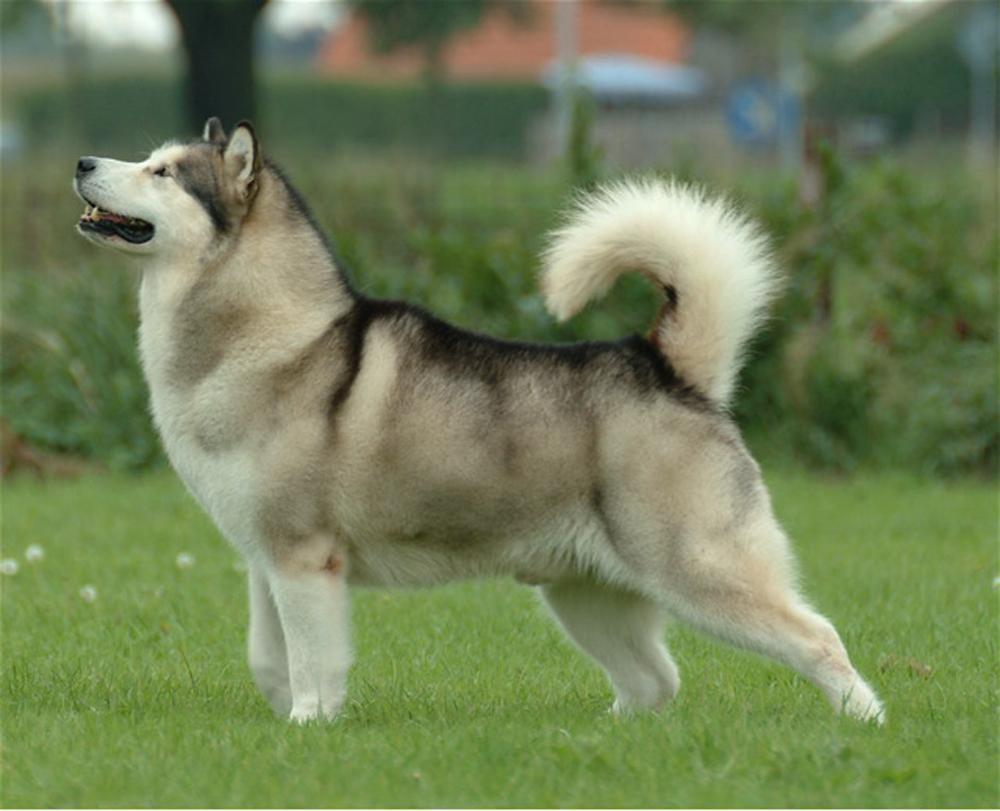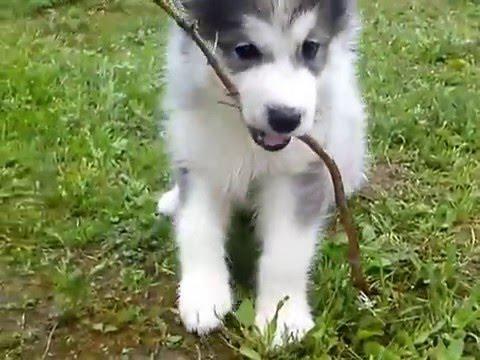The first image is the image on the left, the second image is the image on the right. Given the left and right images, does the statement "Both dogs have their tongues out." hold true? Answer yes or no. No. The first image is the image on the left, the second image is the image on the right. Assess this claim about the two images: "The dog in the image on the left has its tail up and curled over its back.". Correct or not? Answer yes or no. Yes. 